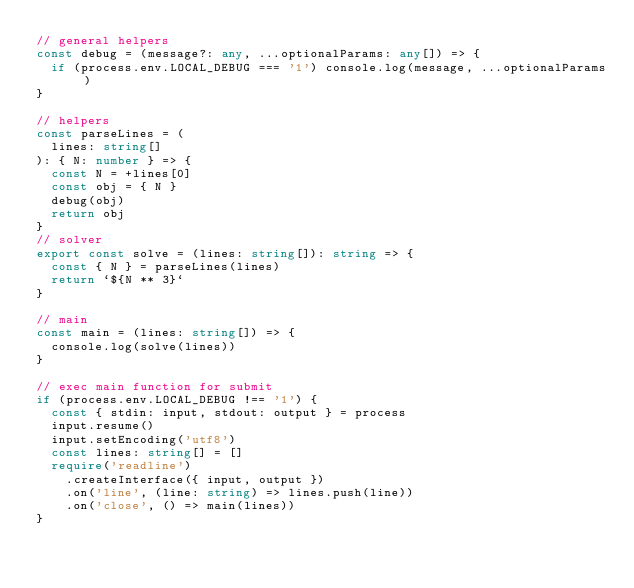<code> <loc_0><loc_0><loc_500><loc_500><_TypeScript_>// general helpers
const debug = (message?: any, ...optionalParams: any[]) => {
  if (process.env.LOCAL_DEBUG === '1') console.log(message, ...optionalParams)
}

// helpers
const parseLines = (
  lines: string[]
): { N: number } => {
  const N = +lines[0]
  const obj = { N }
  debug(obj)
  return obj
}
// solver
export const solve = (lines: string[]): string => {
  const { N } = parseLines(lines)
  return `${N ** 3}`
}

// main
const main = (lines: string[]) => {
  console.log(solve(lines))
}

// exec main function for submit
if (process.env.LOCAL_DEBUG !== '1') {
  const { stdin: input, stdout: output } = process
  input.resume()
  input.setEncoding('utf8')
  const lines: string[] = []
  require('readline')
    .createInterface({ input, output })
    .on('line', (line: string) => lines.push(line))
    .on('close', () => main(lines))
}
</code> 